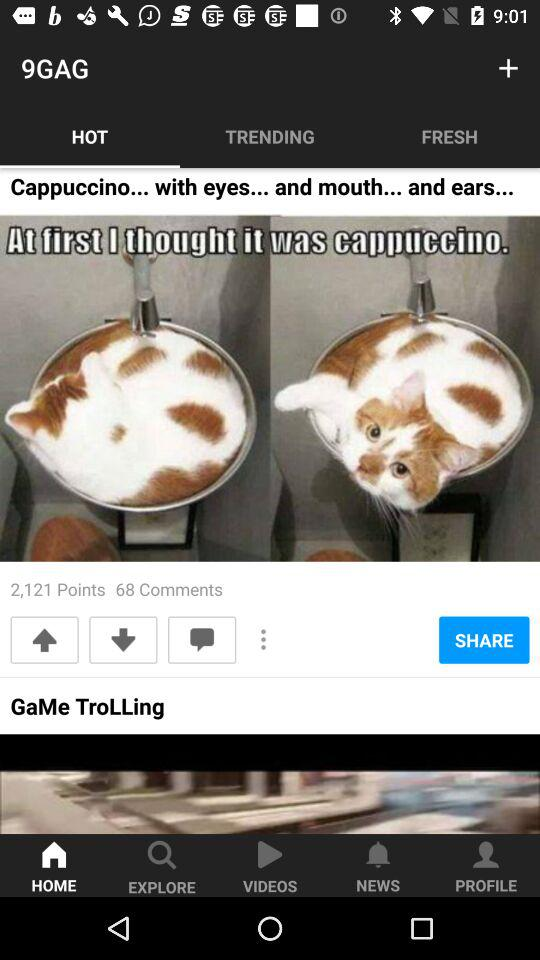How many comments are there on this post?
Answer the question using a single word or phrase. 68 